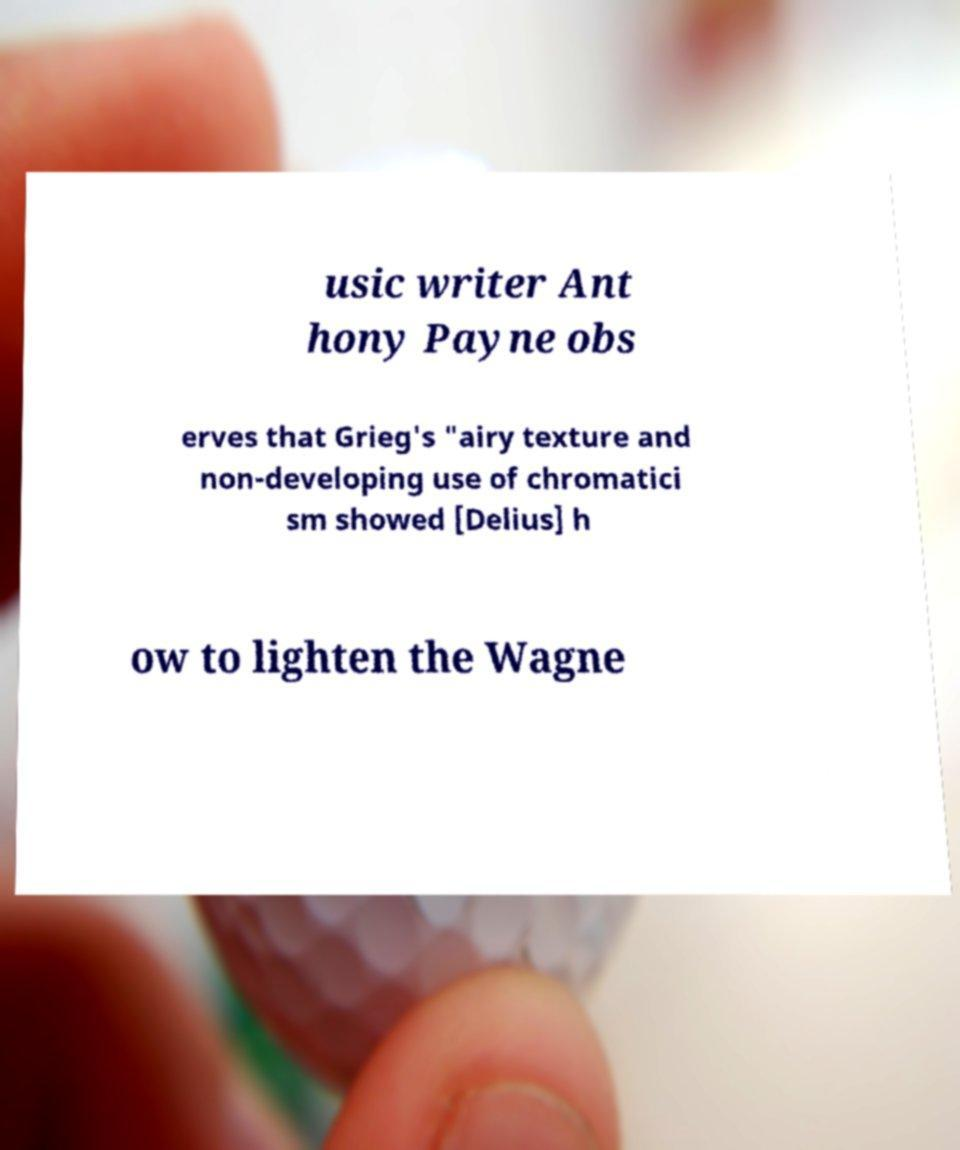For documentation purposes, I need the text within this image transcribed. Could you provide that? usic writer Ant hony Payne obs erves that Grieg's "airy texture and non-developing use of chromatici sm showed [Delius] h ow to lighten the Wagne 